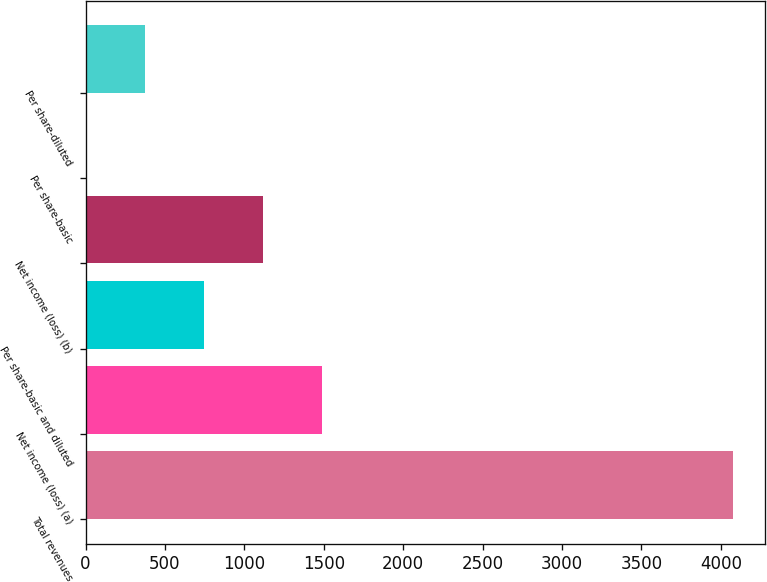Convert chart. <chart><loc_0><loc_0><loc_500><loc_500><bar_chart><fcel>Total revenues<fcel>Net income (loss) (a)<fcel>Per share-basic and diluted<fcel>Net income (loss) (b)<fcel>Per share-basic<fcel>Per share-diluted<nl><fcel>4075.45<fcel>1486.28<fcel>743.37<fcel>1114.83<fcel>0.45<fcel>371.91<nl></chart> 